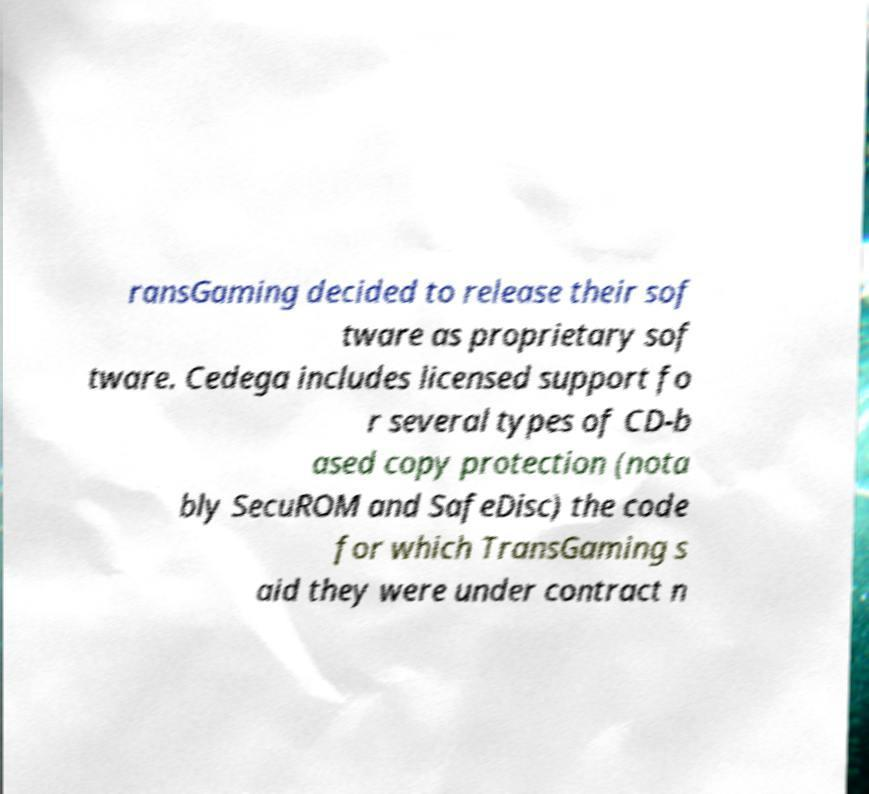Please identify and transcribe the text found in this image. ransGaming decided to release their sof tware as proprietary sof tware. Cedega includes licensed support fo r several types of CD-b ased copy protection (nota bly SecuROM and SafeDisc) the code for which TransGaming s aid they were under contract n 